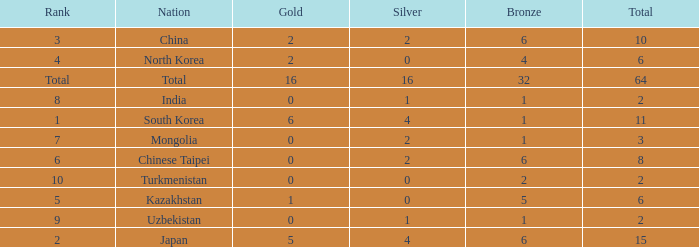How many Golds did Rank 10 get, with a Bronze larger than 2? 0.0. 